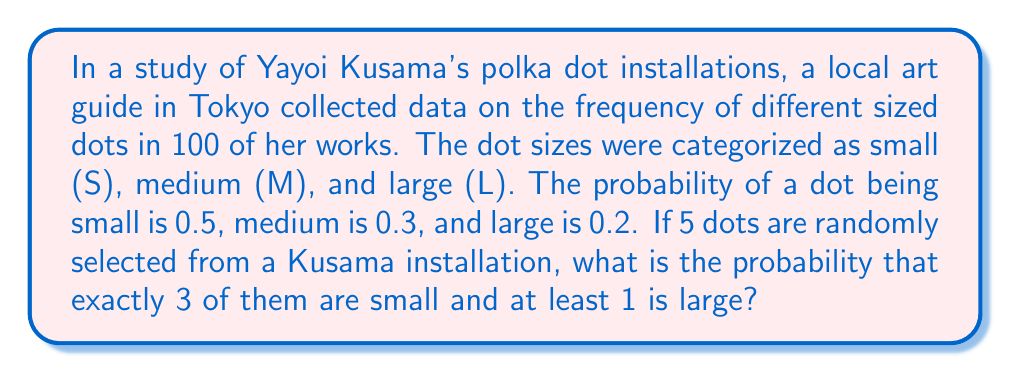Provide a solution to this math problem. Let's approach this step-by-step using the binomial distribution and the complement rule:

1) First, we need to calculate the probability of exactly 3 small dots out of 5:
   $P(3S) = \binom{5}{3} (0.5)^3 (0.5)^2 = 10 \cdot 0.125 \cdot 0.25 = 0.3125$

2) Now, we need the probability of at least 1 large dot out of the remaining 2:
   $P(\text{at least 1L out of 2}) = 1 - P(\text{no L out of 2})$

3) The probability of no large dots out of 2 is:
   $P(\text{no L out of 2}) = (0.3 + 0.2)^2 = 0.5^2 = 0.25$

4) Therefore, the probability of at least 1 large out of 2 is:
   $P(\text{at least 1L out of 2}) = 1 - 0.25 = 0.75$

5) The events of having 3 small dots and at least 1 large dot out of the remaining 2 are independent, so we multiply their probabilities:

   $P(3S \text{ and at least 1L}) = P(3S) \cdot P(\text{at least 1L out of 2})$
   $= 0.3125 \cdot 0.75 = 0.234375$
Answer: $0.234375$ 